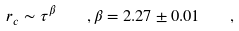Convert formula to latex. <formula><loc_0><loc_0><loc_500><loc_500>r _ { c } \sim \tau ^ { \beta } \quad , \beta = 2 . 2 7 \pm 0 . 0 1 \quad ,</formula> 